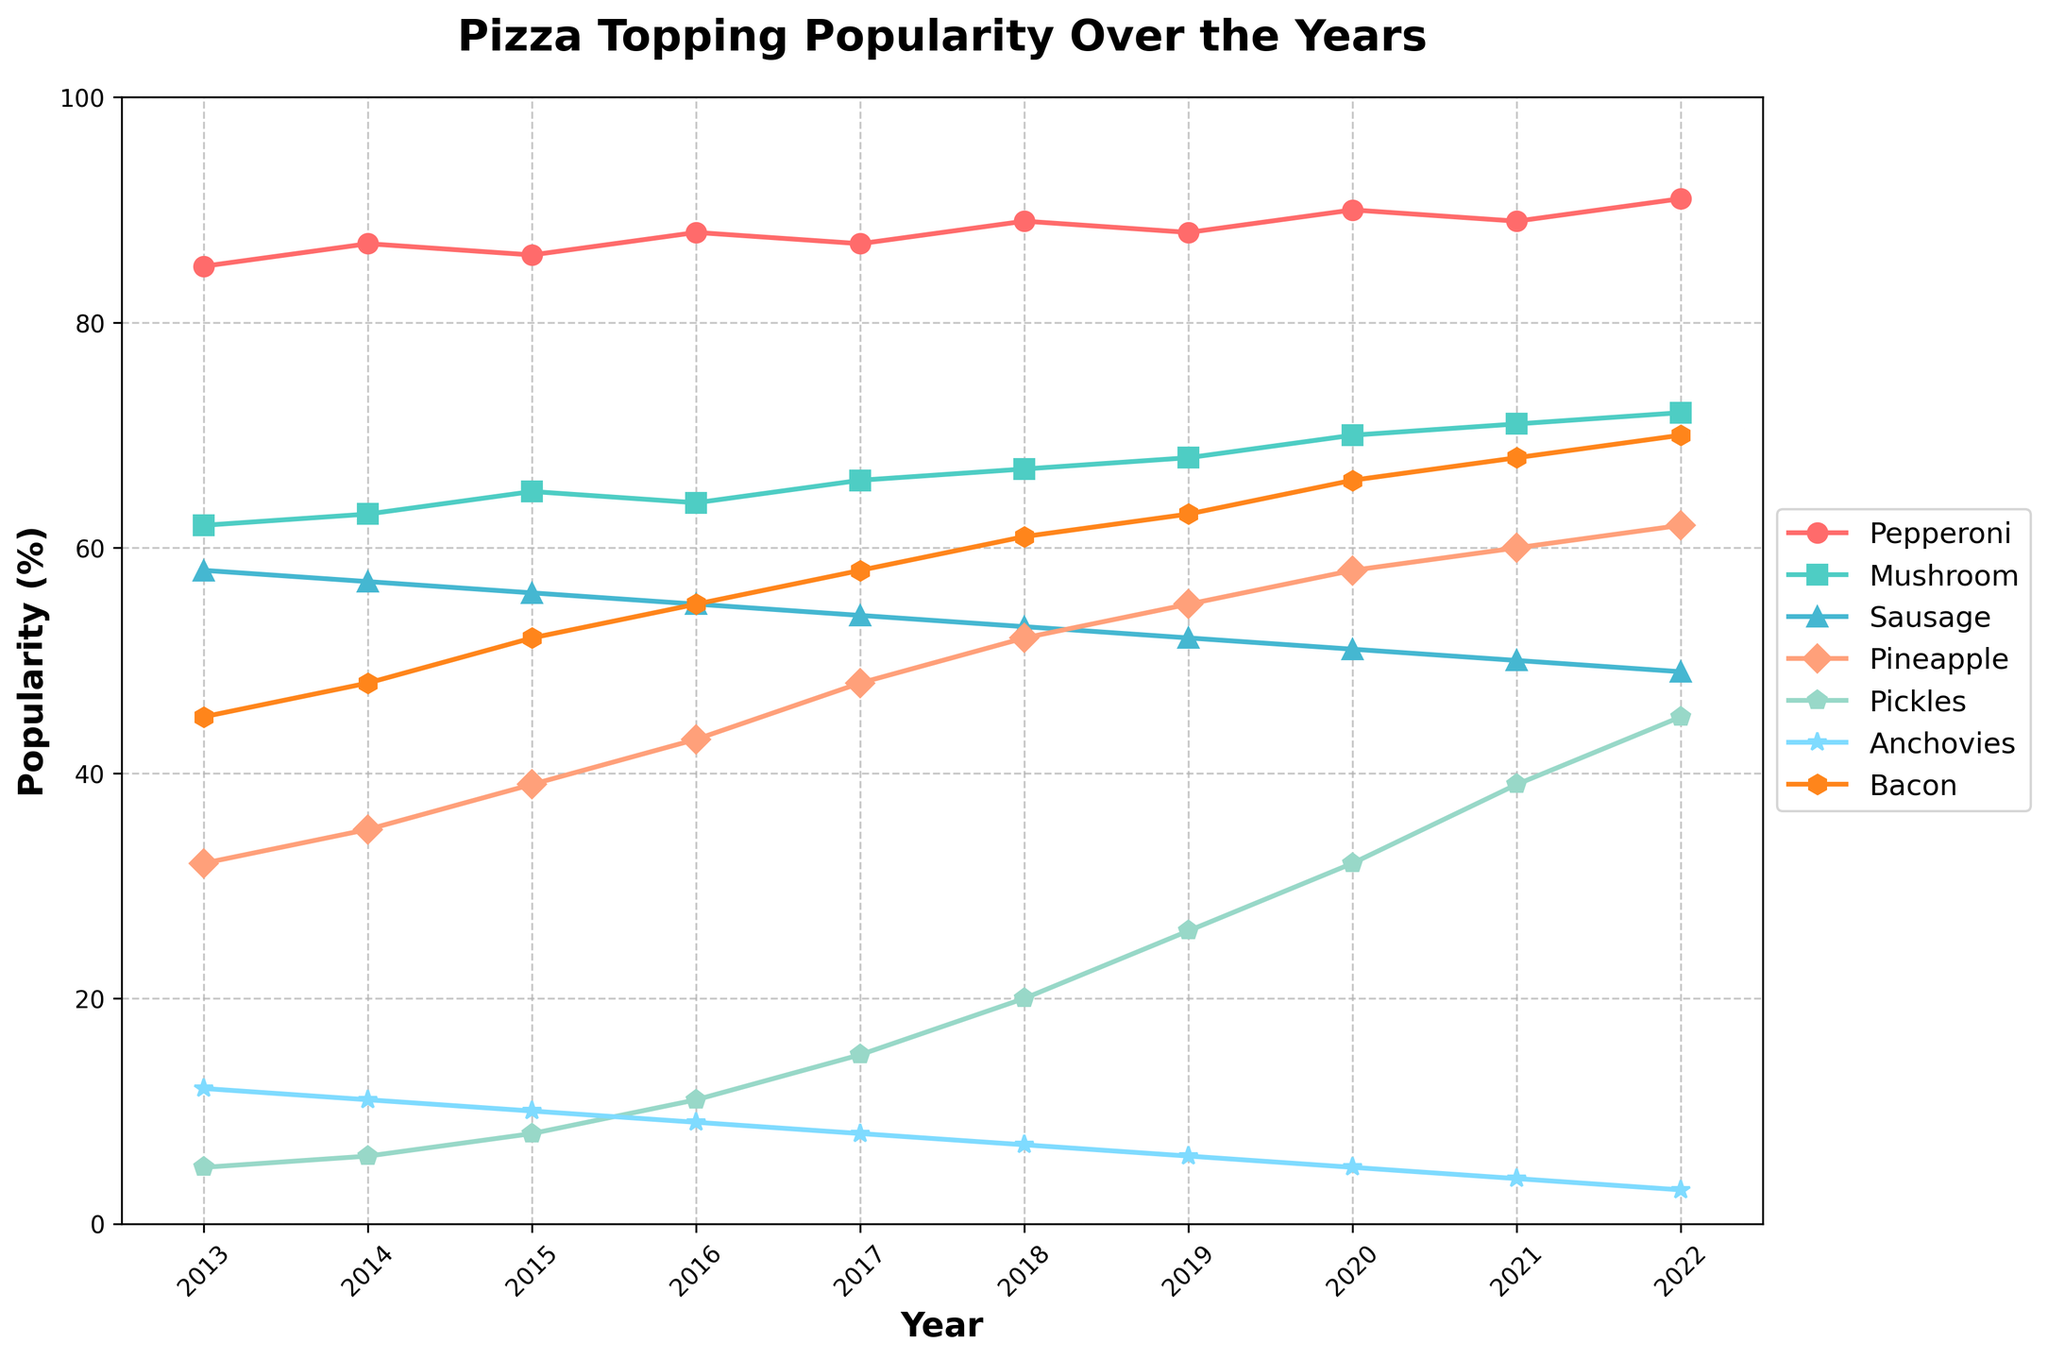What's the most popular pizza topping in 2022? The data shows different toppings’ popularity over the years. By looking at the peak values in 2022, Pepperoni has the highest percentage.
Answer: Pepperoni From 2013 to 2022, by how much did pineapple's popularity increase? Pineapple's popularity in 2013 was 32%, and in 2022 it was 62%. The difference is 62 - 32 = 30%.
Answer: 30% Which topping had the most significant decrease in popularity over the decade? Anchovies' popularity dropped from 12% in 2013 to 3% in 2022, showing a decrease of 12 - 3 = 9%. This is the largest decrease among all toppings.
Answer: Anchovies In which year did pickle's popularity surpass the 20% mark? Reviewing the plot, pickles' popularity first exceeds 20% in 2018, reaching 20%.
Answer: 2018 Compare the popularity trend of mushroom and sausages from 2016 to 2022. Which one had a steady increase, and which one declined? Checking data from 2016 to 2022, mushrooms increased from 64% to 72%, while sausages declined from 55% to 49%.
Answer: Mushroom increased, sausage declined If you combine the popularity percentages of bacon and mushroom in 2021, what would be the total? In 2021, bacon is at 68% and mushroom at 71%. Adding them gives 68 + 71 = 139%.
Answer: 139% Which topping showed the steepest increase in popularity in a single year? Pineapple illustrated the most substantial increase from 2019 (55%) to 2020 (58%), climbing 3% in one year.
Answer: Pineapple What's the average popularity of pickles over the decade? To find the average, sum all pickle percentages (5+6+8+11+15+20+26+32+39+45 = 207) and divide by 10 years. 207 / 10 = 20.7%.
Answer: 20.7% How did bacon's popularity change from 2013 to 2022? Bacon increased from 45% in 2013 to 70% in 2022, indicating a rise of 70 - 45 = 25%.
Answer: 25% Which topping had the lowest popularity in 2013, and did it ever surpass 10% popularity in subsequent years? Pickles had the lowest at 5% in 2013. They exceeded 10% from 2016 onward.
Answer: Pickles, Yes 